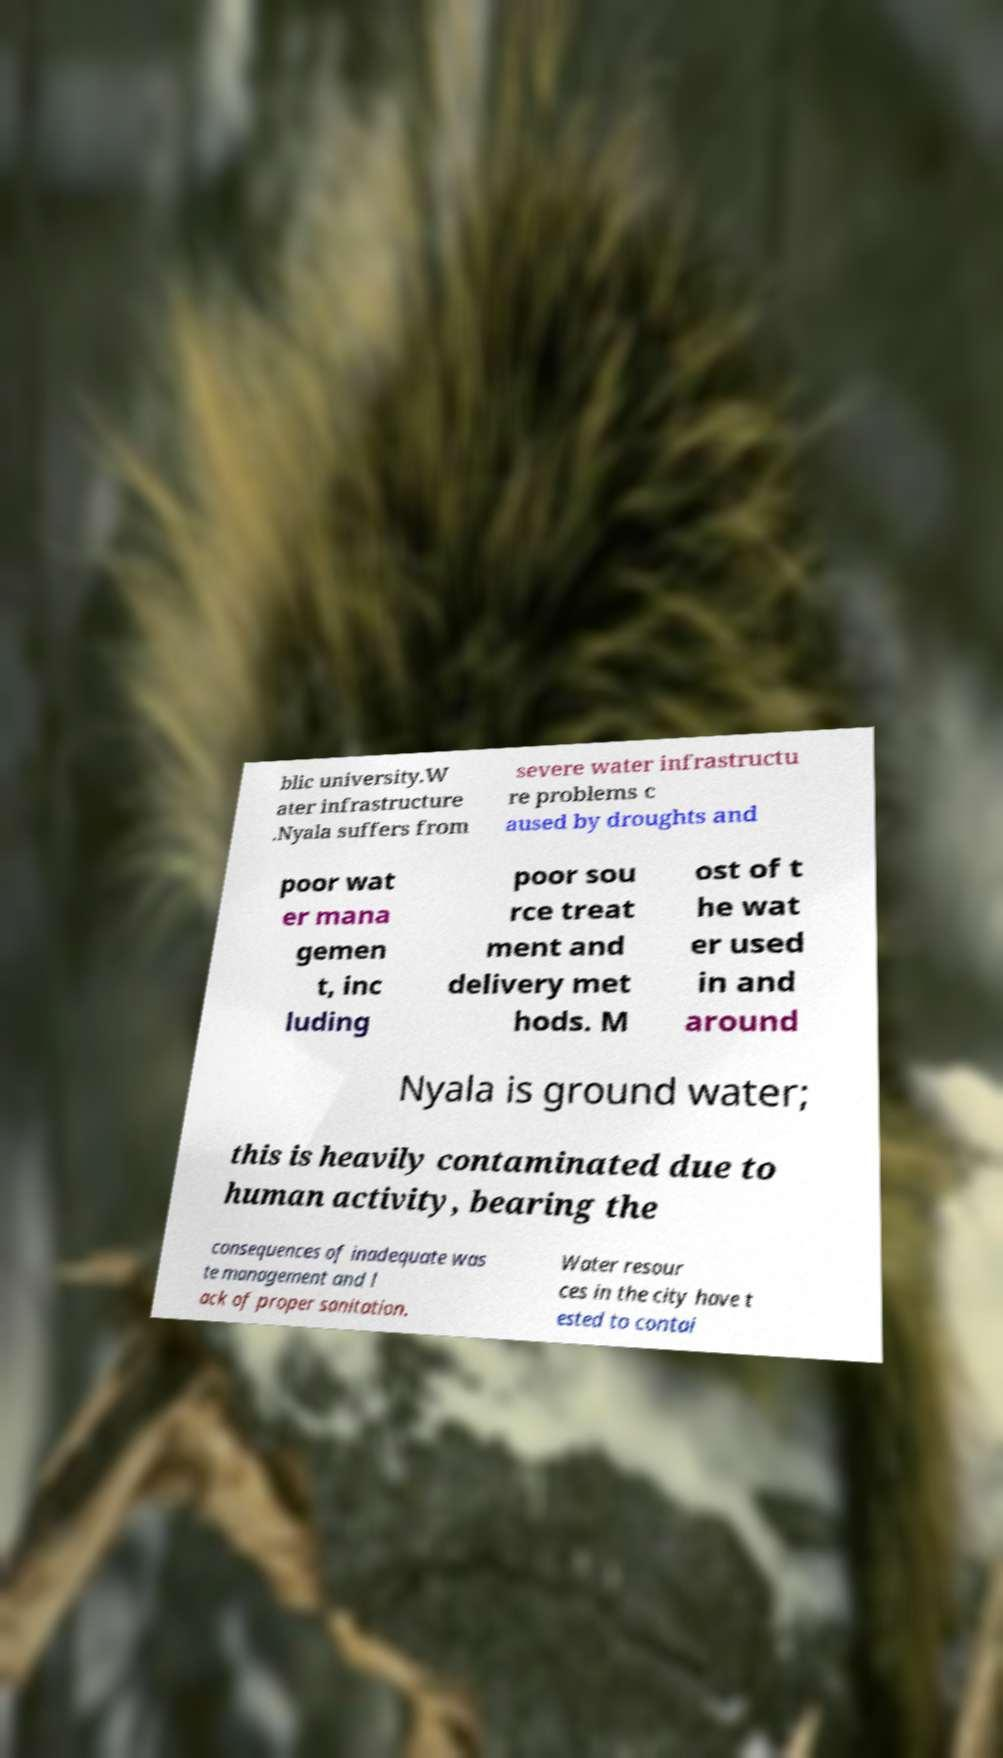I need the written content from this picture converted into text. Can you do that? blic university.W ater infrastructure .Nyala suffers from severe water infrastructu re problems c aused by droughts and poor wat er mana gemen t, inc luding poor sou rce treat ment and delivery met hods. M ost of t he wat er used in and around Nyala is ground water; this is heavily contaminated due to human activity, bearing the consequences of inadequate was te management and l ack of proper sanitation. Water resour ces in the city have t ested to contai 